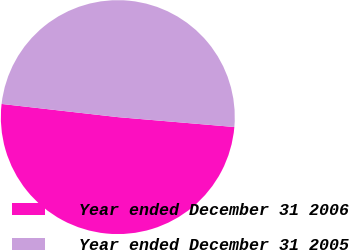Convert chart. <chart><loc_0><loc_0><loc_500><loc_500><pie_chart><fcel>Year ended December 31 2006<fcel>Year ended December 31 2005<nl><fcel>50.45%<fcel>49.55%<nl></chart> 